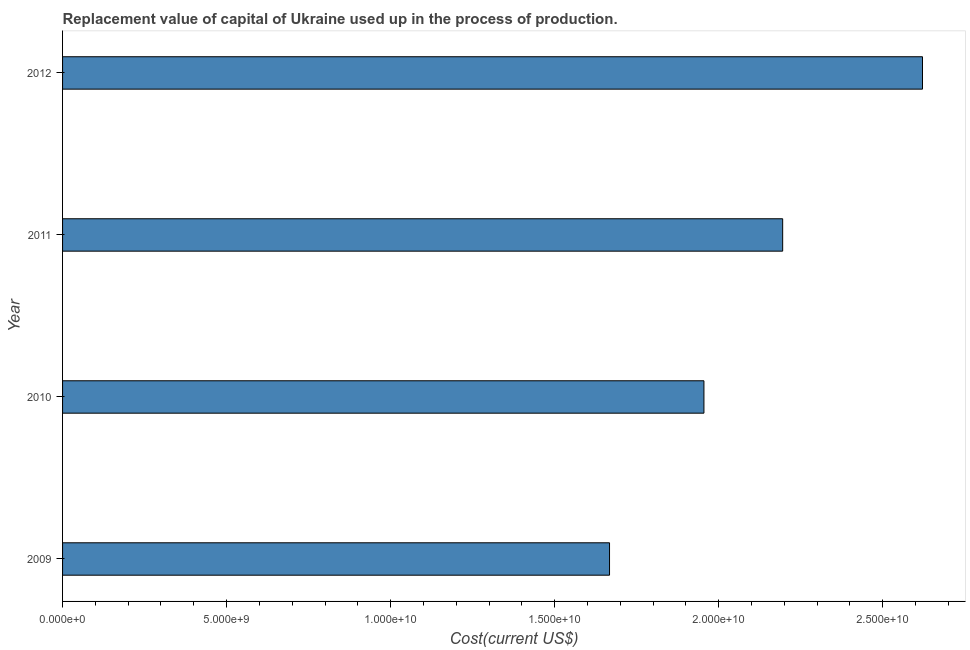Does the graph contain grids?
Ensure brevity in your answer.  No. What is the title of the graph?
Your answer should be compact. Replacement value of capital of Ukraine used up in the process of production. What is the label or title of the X-axis?
Provide a succinct answer. Cost(current US$). What is the consumption of fixed capital in 2011?
Your response must be concise. 2.20e+1. Across all years, what is the maximum consumption of fixed capital?
Provide a short and direct response. 2.62e+1. Across all years, what is the minimum consumption of fixed capital?
Make the answer very short. 1.67e+1. In which year was the consumption of fixed capital maximum?
Ensure brevity in your answer.  2012. In which year was the consumption of fixed capital minimum?
Your answer should be compact. 2009. What is the sum of the consumption of fixed capital?
Offer a terse response. 8.44e+1. What is the difference between the consumption of fixed capital in 2009 and 2012?
Make the answer very short. -9.54e+09. What is the average consumption of fixed capital per year?
Make the answer very short. 2.11e+1. What is the median consumption of fixed capital?
Make the answer very short. 2.08e+1. In how many years, is the consumption of fixed capital greater than 3000000000 US$?
Your answer should be compact. 4. Do a majority of the years between 2011 and 2010 (inclusive) have consumption of fixed capital greater than 3000000000 US$?
Your response must be concise. No. What is the ratio of the consumption of fixed capital in 2009 to that in 2012?
Provide a succinct answer. 0.64. Is the consumption of fixed capital in 2009 less than that in 2012?
Give a very brief answer. Yes. Is the difference between the consumption of fixed capital in 2009 and 2011 greater than the difference between any two years?
Provide a short and direct response. No. What is the difference between the highest and the second highest consumption of fixed capital?
Ensure brevity in your answer.  4.26e+09. What is the difference between the highest and the lowest consumption of fixed capital?
Offer a very short reply. 9.54e+09. Are all the bars in the graph horizontal?
Provide a short and direct response. Yes. Are the values on the major ticks of X-axis written in scientific E-notation?
Your answer should be compact. Yes. What is the Cost(current US$) in 2009?
Give a very brief answer. 1.67e+1. What is the Cost(current US$) in 2010?
Ensure brevity in your answer.  1.96e+1. What is the Cost(current US$) of 2011?
Your response must be concise. 2.20e+1. What is the Cost(current US$) in 2012?
Provide a short and direct response. 2.62e+1. What is the difference between the Cost(current US$) in 2009 and 2010?
Give a very brief answer. -2.88e+09. What is the difference between the Cost(current US$) in 2009 and 2011?
Offer a very short reply. -5.28e+09. What is the difference between the Cost(current US$) in 2009 and 2012?
Offer a terse response. -9.54e+09. What is the difference between the Cost(current US$) in 2010 and 2011?
Make the answer very short. -2.40e+09. What is the difference between the Cost(current US$) in 2010 and 2012?
Provide a succinct answer. -6.66e+09. What is the difference between the Cost(current US$) in 2011 and 2012?
Give a very brief answer. -4.26e+09. What is the ratio of the Cost(current US$) in 2009 to that in 2010?
Your response must be concise. 0.85. What is the ratio of the Cost(current US$) in 2009 to that in 2011?
Your response must be concise. 0.76. What is the ratio of the Cost(current US$) in 2009 to that in 2012?
Offer a terse response. 0.64. What is the ratio of the Cost(current US$) in 2010 to that in 2011?
Provide a short and direct response. 0.89. What is the ratio of the Cost(current US$) in 2010 to that in 2012?
Keep it short and to the point. 0.75. What is the ratio of the Cost(current US$) in 2011 to that in 2012?
Offer a very short reply. 0.84. 